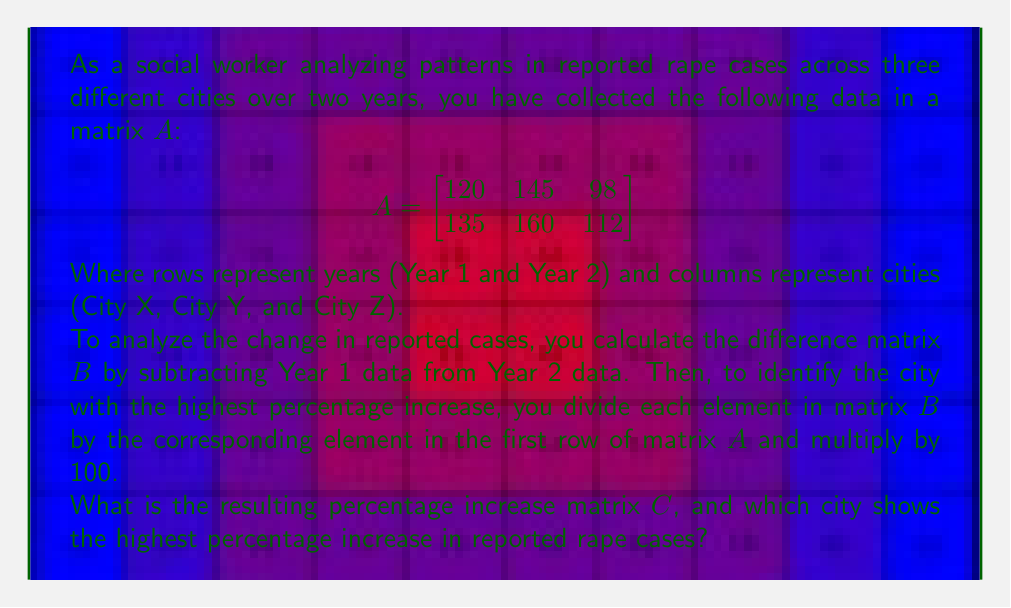Teach me how to tackle this problem. Let's approach this step-by-step:

1) First, we need to calculate matrix $B$ by subtracting the first row of $A$ from the second row:

   $$B = \begin{bmatrix}
   135 - 120 & 160 - 145 & 112 - 98
   \end{bmatrix} = \begin{bmatrix}
   15 & 15 & 14
   \end{bmatrix}$$

2) Now, we need to divide each element of $B$ by the corresponding element in the first row of $A$ and multiply by 100 to get the percentage increase matrix $C$:

   For City X: $\frac{15}{120} \times 100 = 12.5\%$
   For City Y: $\frac{15}{145} \times 100 \approx 10.34\%$
   For City Z: $\frac{14}{98} \times 100 \approx 14.29\%$

3) Therefore, the percentage increase matrix $C$ is:

   $$C = \begin{bmatrix}
   12.5 & 10.34 & 14.29
   \end{bmatrix}$$

4) Looking at matrix $C$, we can see that the highest percentage is 14.29%, which corresponds to City Z.
Answer: The percentage increase matrix $C$ is approximately:

$$C = \begin{bmatrix}
12.5 & 10.34 & 14.29
\end{bmatrix}$$

City Z shows the highest percentage increase in reported rape cases at approximately 14.29%. 